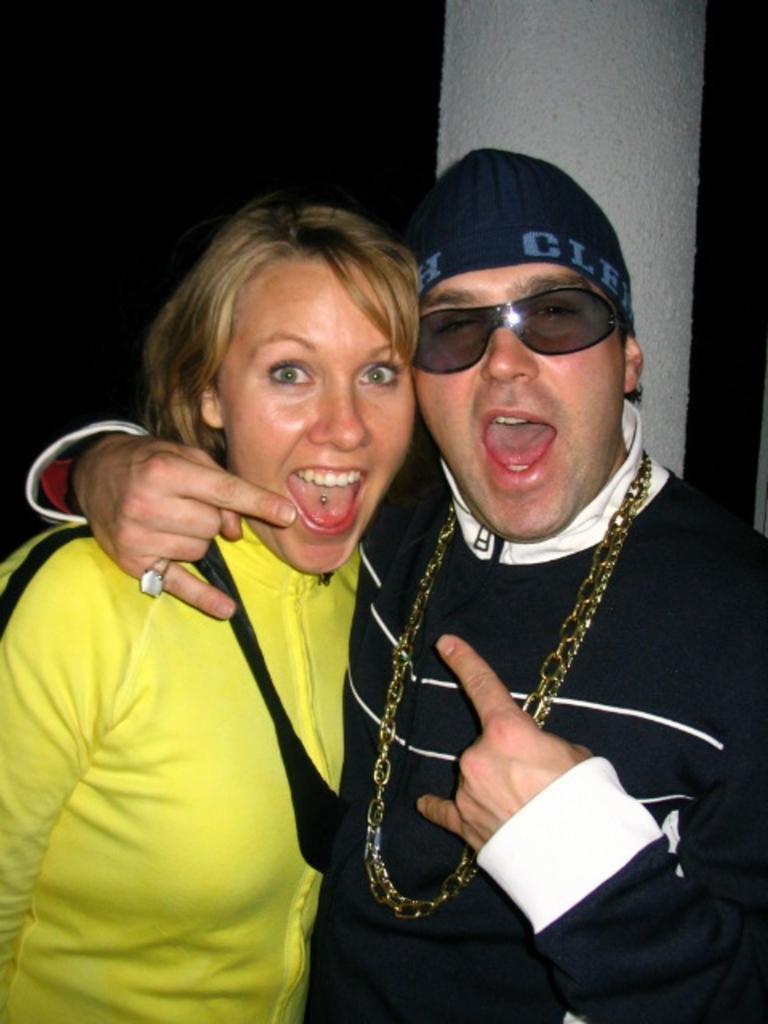Could you give a brief overview of what you see in this image? In the image I can see two people standing. I can see a woman wearing a yellow dress on the left side of the image. I can see a person wearing glasses.  